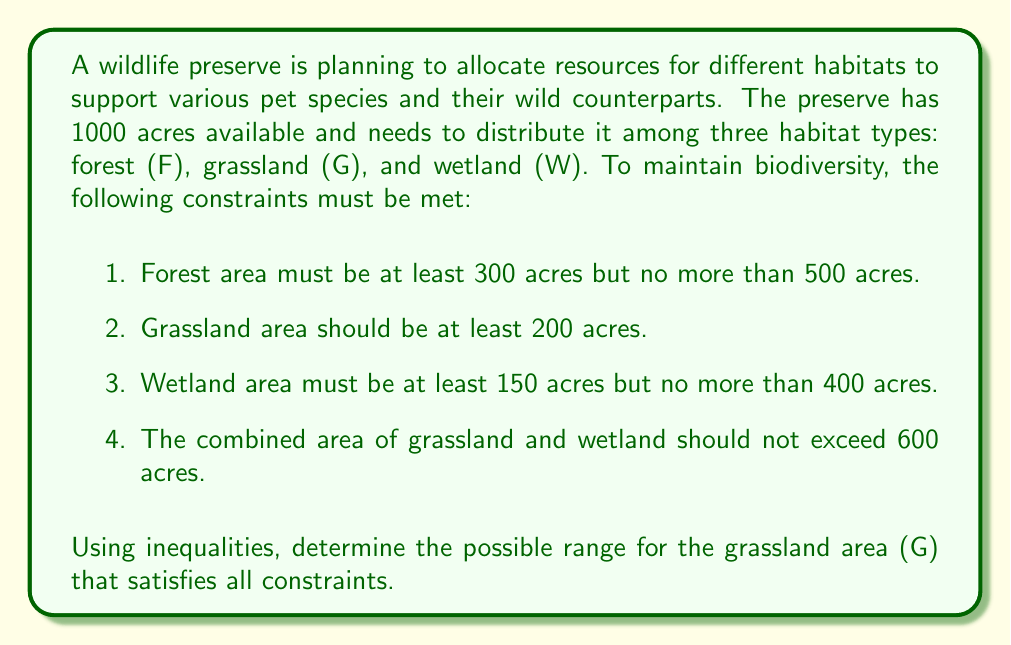Can you solve this math problem? Let's approach this step-by-step:

1. First, let's write out the inequalities based on the given constraints:

   Forest (F): $300 \leq F \leq 500$
   Grassland (G): $G \geq 200$
   Wetland (W): $150 \leq W \leq 400$
   Total area: $F + G + W = 1000$
   Grassland and Wetland combined: $G + W \leq 600$

2. We need to find the range for G. Let's start with the lower bound:
   We know $G \geq 200$, so the lower bound is 200.

3. For the upper bound, we need to consider multiple constraints:

   a) From $G + W \leq 600$ and $W \geq 150$, we can deduce:
      $G \leq 600 - 150 = 450$

   b) From the total area constraint:
      $F + G + W = 1000$
      $G = 1000 - F - W$

      Using the minimum values for F and W:
      $G \leq 1000 - 300 - 150 = 550$

4. Combining these upper bounds, we take the smaller value:
   $G \leq \min(450, 550) = 450$

5. Therefore, the range for G that satisfies all constraints is:

   $200 \leq G \leq 450$

This inequality ensures that the grassland area is at least 200 acres (as required) and no more than 450 acres (to satisfy the combined grassland and wetland constraint while allowing minimum areas for forest and wetland).
Answer: $200 \leq G \leq 450$ 